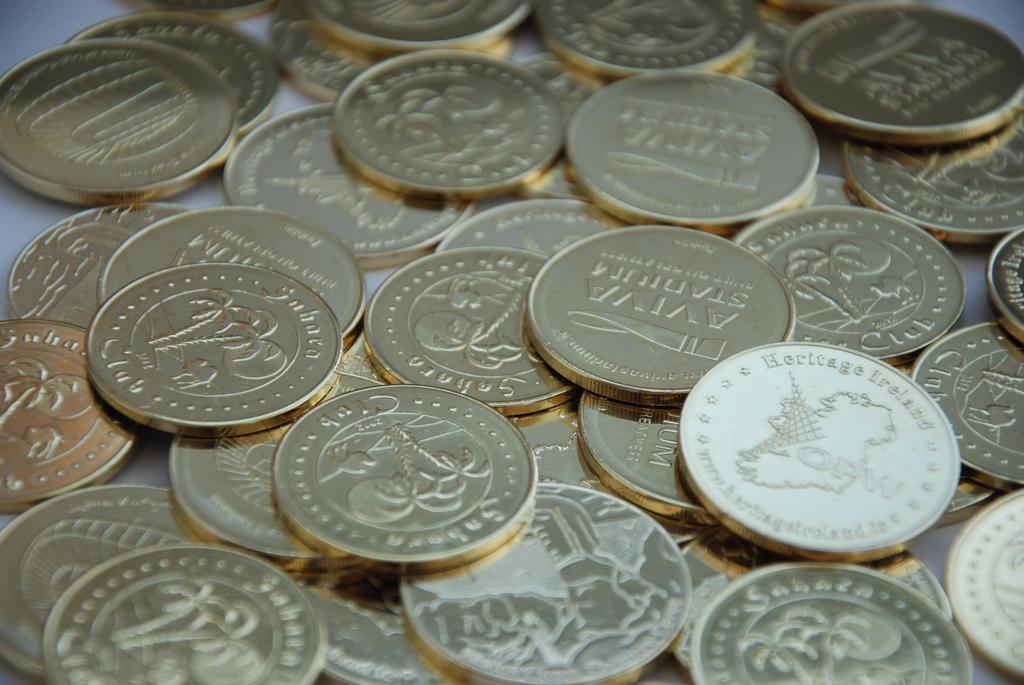<image>
Render a clear and concise summary of the photo. pile of goldish coins, one labeled Heritage Ireland 